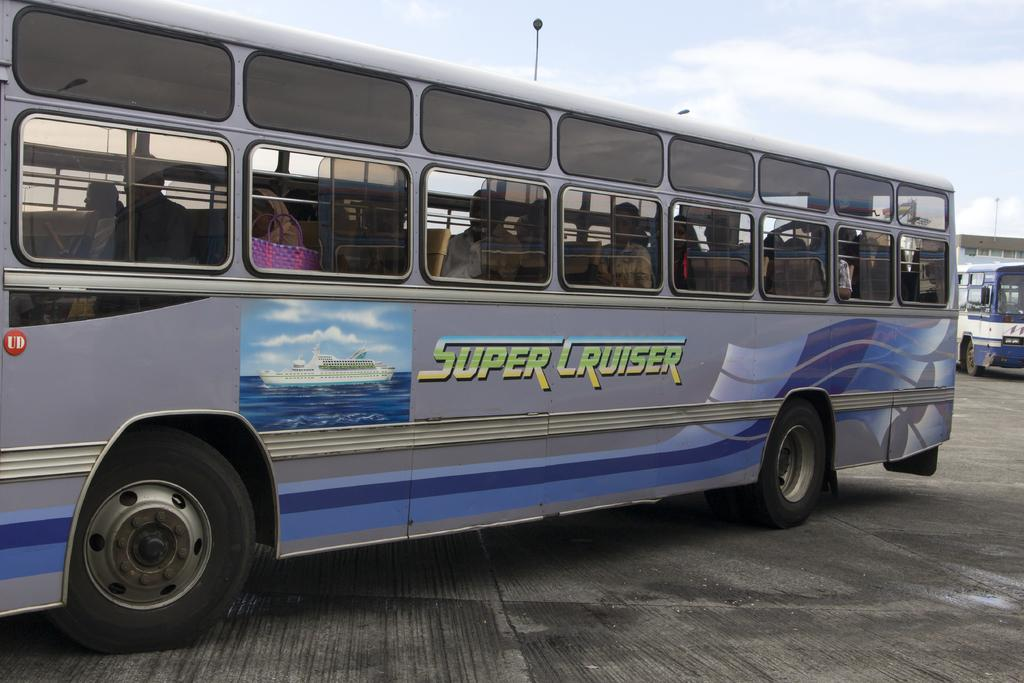What is happening on the road in the image? There are people in a vehicle visible on the road. What type of vehicle can be seen in the image? There is a bus in the image. What structure is present in the image? There is a building in the image. How would you describe the sky in the image? The sky is cloudy in the image. What time of day is it at the farm in the image? There is no farm present in the image, so it is not possible to determine the time of day. 